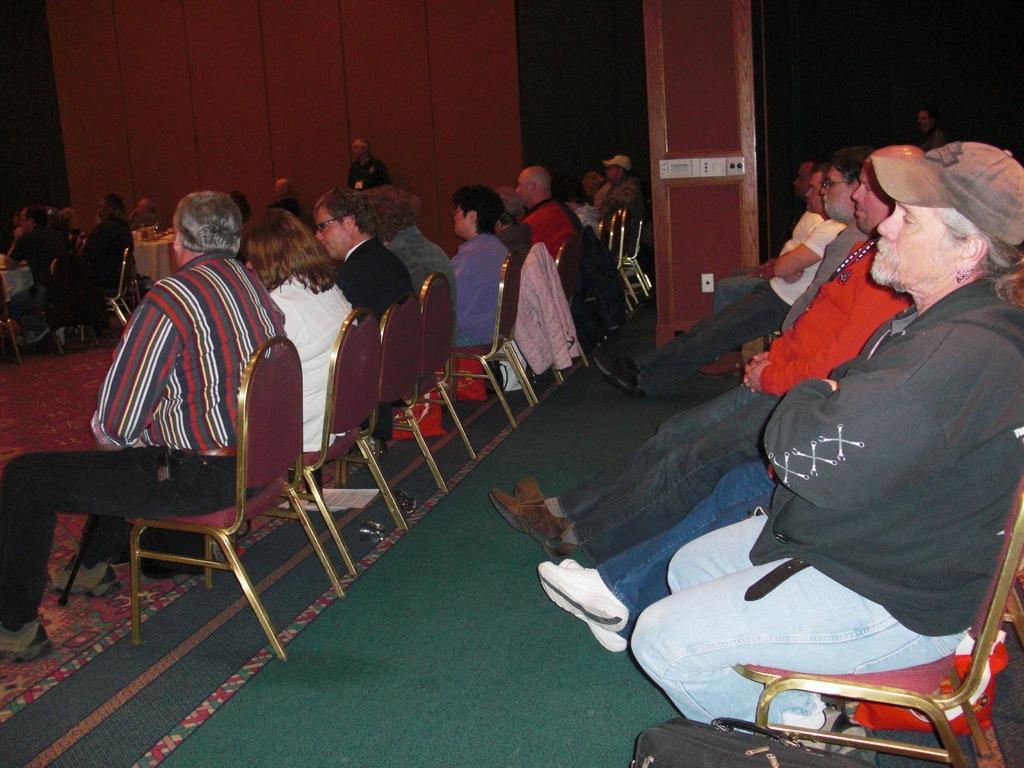Could you give a brief overview of what you see in this image? In this image, we can see persons wearing clothes and sitting on chairs. There is a wall at the top of the image. There is a bag at the bottom of the image. 